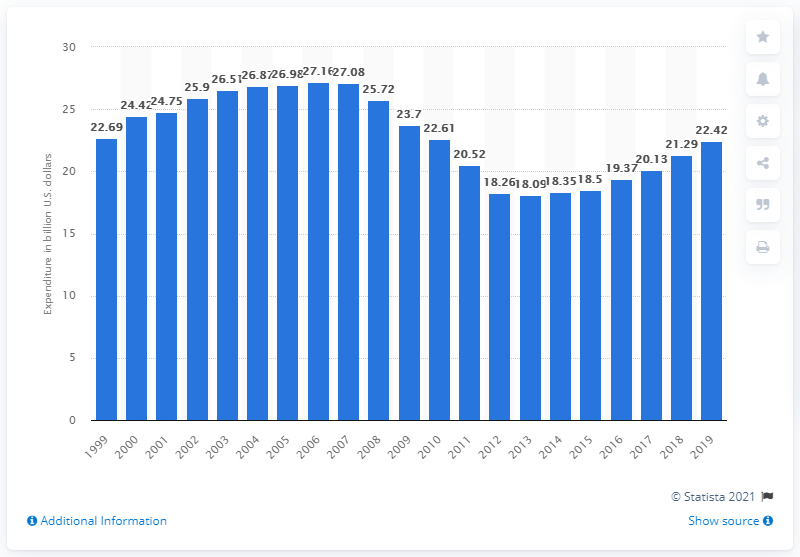List a handful of essential elements in this visual. In the United States, Americans spend approximately 21.29 dollars on recreational books annually. The consumer expenditure on recreational books a year earlier was 21.29.. In 2019, the consumer expenditure on recreational books in the United States was 22.42 dollars. 